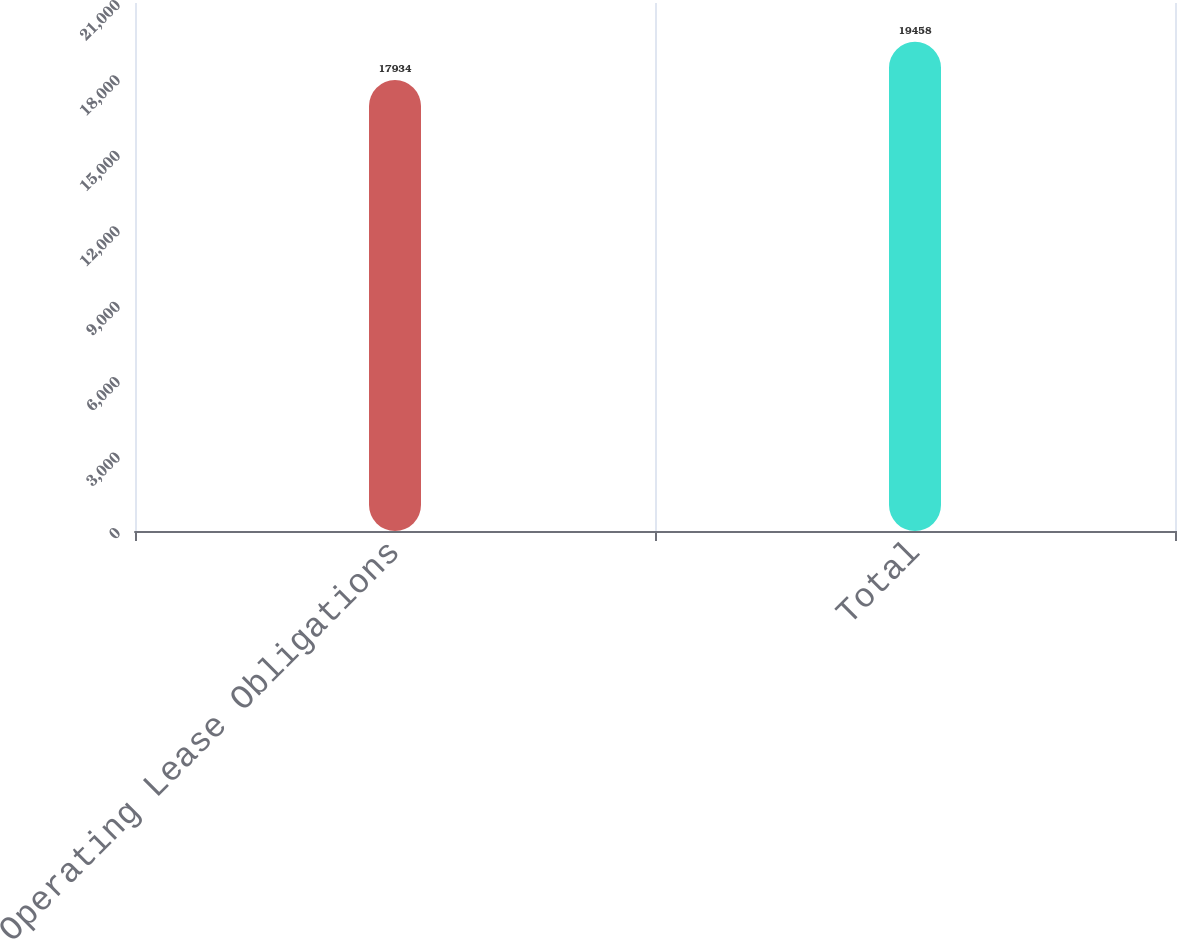<chart> <loc_0><loc_0><loc_500><loc_500><bar_chart><fcel>Operating Lease Obligations<fcel>Total<nl><fcel>17934<fcel>19458<nl></chart> 